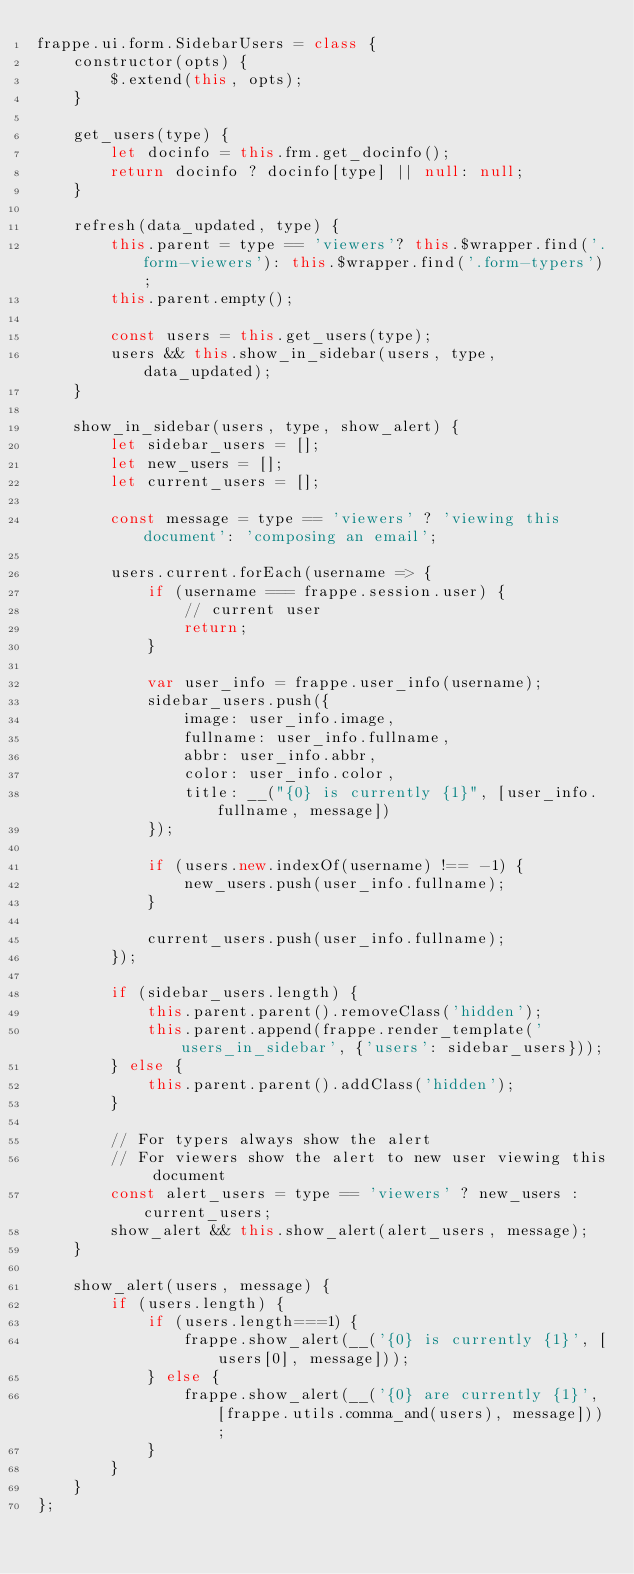Convert code to text. <code><loc_0><loc_0><loc_500><loc_500><_JavaScript_>frappe.ui.form.SidebarUsers = class {
	constructor(opts) {
		$.extend(this, opts);
	}

	get_users(type) {
		let docinfo = this.frm.get_docinfo();
		return docinfo ? docinfo[type] || null: null;
	}

	refresh(data_updated, type) {
		this.parent = type == 'viewers'? this.$wrapper.find('.form-viewers'): this.$wrapper.find('.form-typers');
		this.parent.empty();

		const users = this.get_users(type);
		users && this.show_in_sidebar(users, type, data_updated);
	}

	show_in_sidebar(users, type, show_alert) {
		let sidebar_users = [];
		let new_users = [];
		let current_users = [];

		const message = type == 'viewers' ? 'viewing this document': 'composing an email';

		users.current.forEach(username => {
			if (username === frappe.session.user) {
				// current user
				return;
			}

			var user_info = frappe.user_info(username);
			sidebar_users.push({
				image: user_info.image,
				fullname: user_info.fullname,
				abbr: user_info.abbr,
				color: user_info.color,
				title: __("{0} is currently {1}", [user_info.fullname, message])
			});

			if (users.new.indexOf(username) !== -1) {
				new_users.push(user_info.fullname);
			}

			current_users.push(user_info.fullname);
		});

		if (sidebar_users.length) {
			this.parent.parent().removeClass('hidden');
			this.parent.append(frappe.render_template('users_in_sidebar', {'users': sidebar_users}));
		} else {
			this.parent.parent().addClass('hidden');
		}

		// For typers always show the alert
		// For viewers show the alert to new user viewing this document
		const alert_users = type == 'viewers' ? new_users : current_users;
		show_alert && this.show_alert(alert_users, message);
	}

	show_alert(users, message) {
		if (users.length) {
			if (users.length===1) {
				frappe.show_alert(__('{0} is currently {1}', [users[0], message]));
			} else {
				frappe.show_alert(__('{0} are currently {1}', [frappe.utils.comma_and(users), message]));
			}
		}
	}
};
</code> 